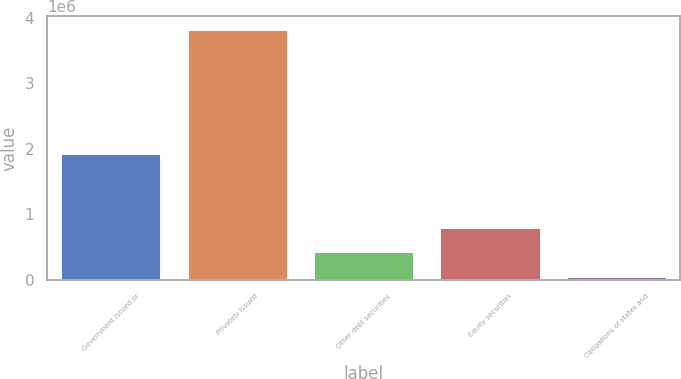Convert chart to OTSL. <chart><loc_0><loc_0><loc_500><loc_500><bar_chart><fcel>Government issued or<fcel>Privately issued<fcel>Other debt securities<fcel>Equity securities<fcel>Obligations of states and<nl><fcel>1.94341e+06<fcel>3.83096e+06<fcel>436589<fcel>813742<fcel>59436<nl></chart> 